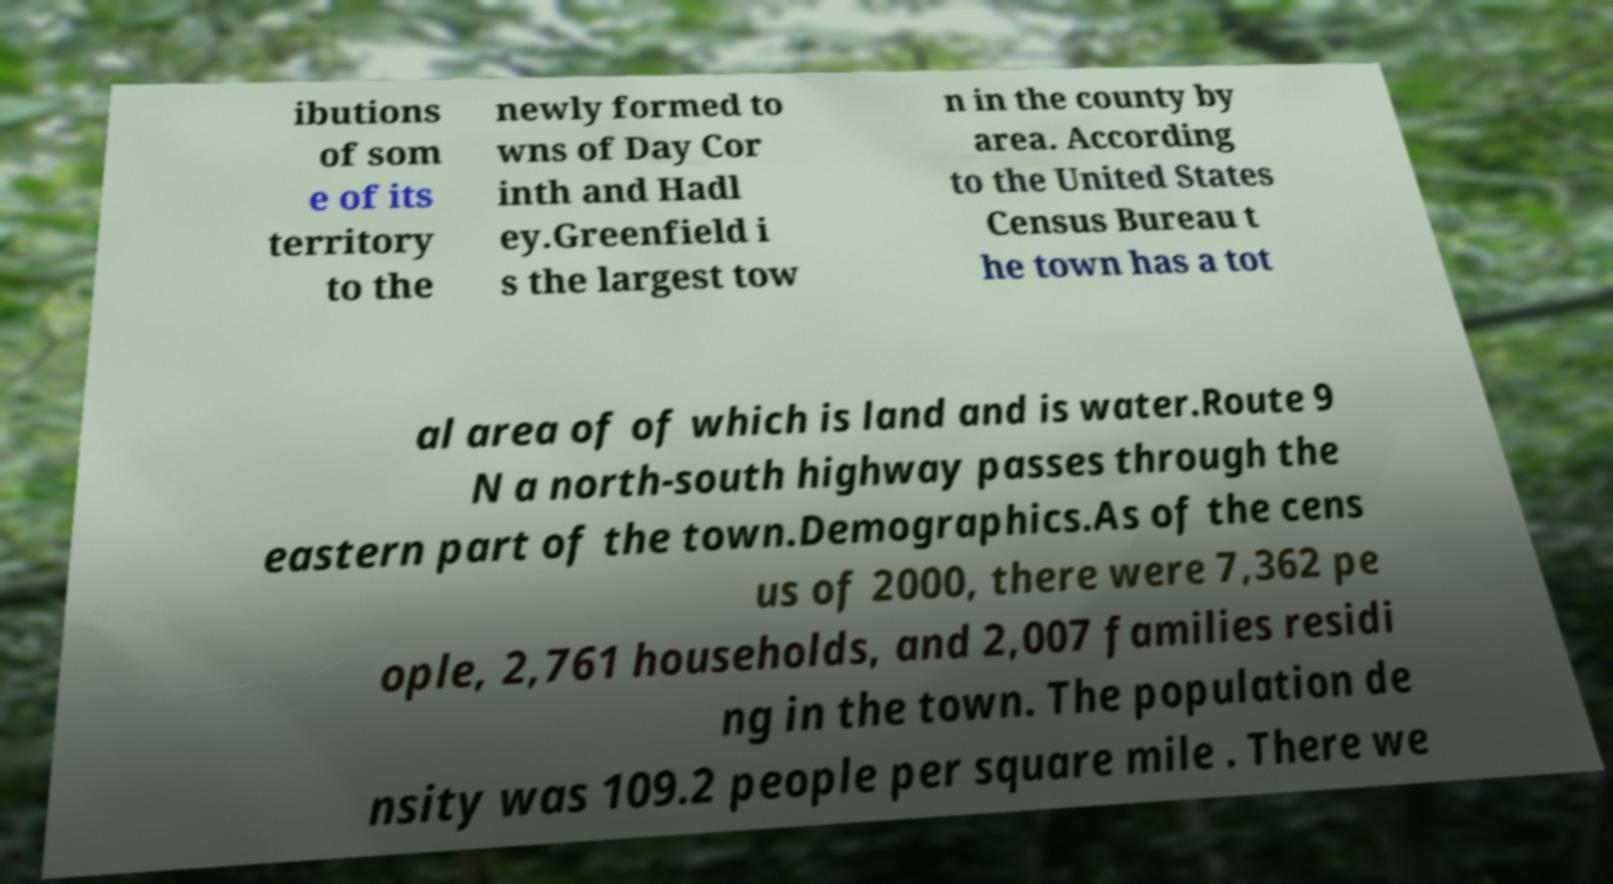What messages or text are displayed in this image? I need them in a readable, typed format. ibutions of som e of its territory to the newly formed to wns of Day Cor inth and Hadl ey.Greenfield i s the largest tow n in the county by area. According to the United States Census Bureau t he town has a tot al area of of which is land and is water.Route 9 N a north-south highway passes through the eastern part of the town.Demographics.As of the cens us of 2000, there were 7,362 pe ople, 2,761 households, and 2,007 families residi ng in the town. The population de nsity was 109.2 people per square mile . There we 